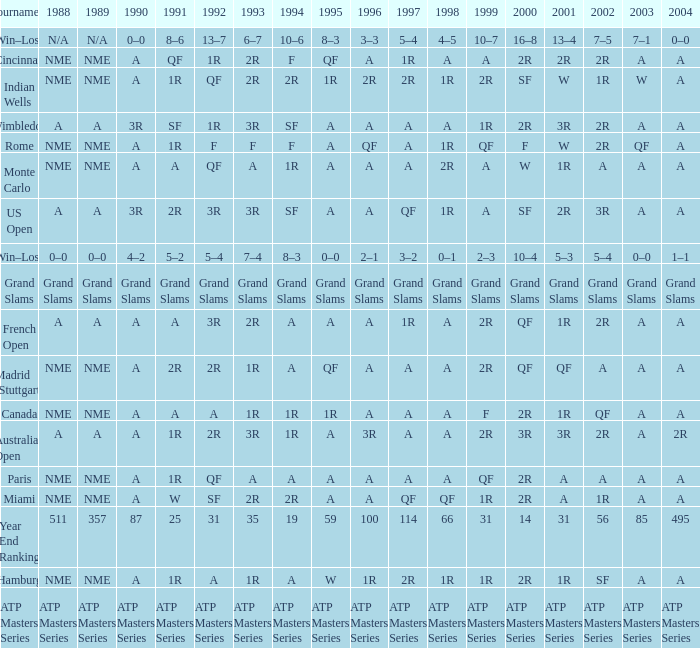What shows for 1992 when 2001 is 1r, 1994 is 1r, and the 2002 is qf? A. 